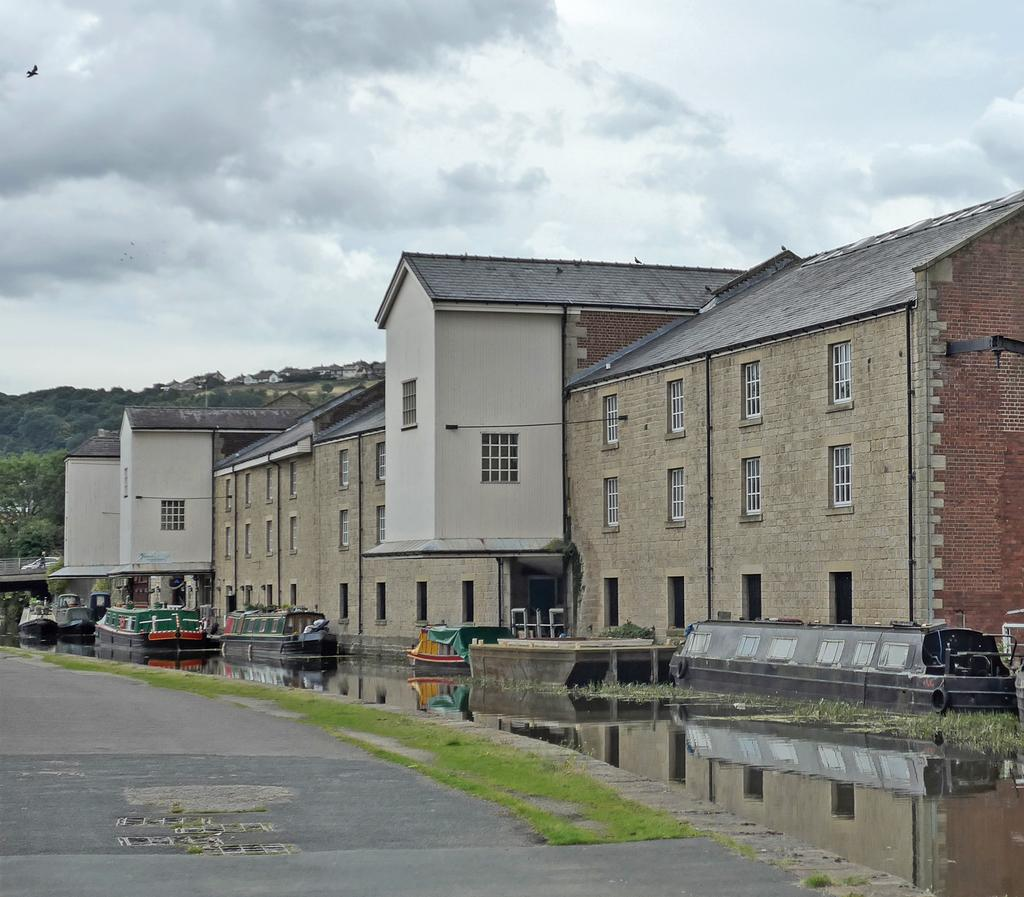What type of structures can be seen in the image? There are buildings in the image. What natural element is visible in the image? There is water visible in the image. What is located at the bottom of the image? There is a road at the bottom of the image. What type of vegetation is on the left side of the image? There are trees on the left side of the image. Can you see the arm of the person taking the picture in the image? There is no person or camera present in the image, so it is not possible to see the arm of the person taking the picture. Is there a skateboard visible in the image? There is no skateboard present in the image. 